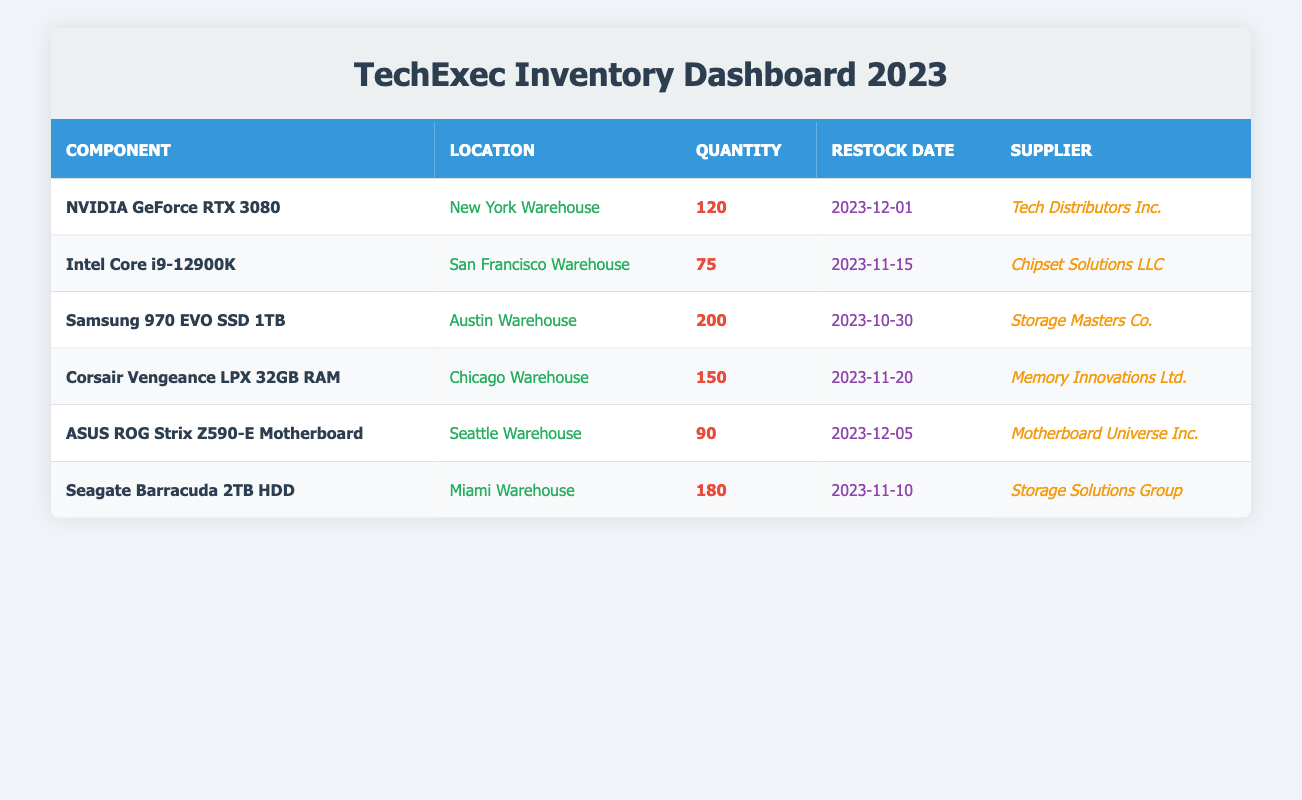What is the total quantity of NVIDIA GeForce RTX 3080 available in the inventory? The table lists the NVIDIA GeForce RTX 3080 with a quantity of 120 in the New York Warehouse, and there are no other entries for this component. Thus, the total quantity is simply 120.
Answer: 120 Which location has the highest stock of hardware components? The table shows various components along with their quantities at different locations. The highest quantity is 200 for the Samsung 970 EVO SSD 1TB at the Austin Warehouse. Therefore, Austin has the highest stock.
Answer: Austin Warehouse Is the Intel Core i9-12900K scheduled for restock before the Seagate Barracuda 2TB HDD? The Intel Core i9-12900K has a restock date of 2023-11-15, while the Seagate Barracuda 2TB HDD has a restock date of 2023-11-10. Since November 10 is before November 15, the statement is true.
Answer: Yes What is the average quantity of the components held in stock across all listed locations? The total stock is calculated by summing the quantities: (120 + 75 + 200 + 150 + 90 + 180) = 915. There are 6 components, so the average is 915 / 6 = 152.5.
Answer: 152.5 How many components have a quantity greater than 100 in stock? Examining the table, the components with quantities above 100 are the NVIDIA GeForce RTX 3080 (120), Samsung 970 EVO SSD 1TB (200), Corsair Vengeance LPX 32GB RAM (150), and Seagate Barracuda 2TB HDD (180). Thus, there are 4 components.
Answer: 4 Is there a supplier for the ASUS ROG Strix Z590-E Motherboard listed in the table? The entry for the ASUS ROG Strix Z590-E Motherboard states its supplier is Motherboard Universe Inc. Therefore, the answer to whether a supplier is listed is affirmative.
Answer: Yes What is the difference in stock quantity between the highest and lowest quantity components? The highest stock is 200 (Samsung 970 EVO SSD 1TB) and the lowest is 75 (Intel Core i9-12900K). The difference is 200 - 75 = 125.
Answer: 125 How many locations feature a restock date in December 2023? The table lists restock dates for two components in December: NVIDIA GeForce RTX 3080 (2023-12-01) and ASUS ROG Strix Z590-E Motherboard (2023-12-05). Therefore, there are 2 locations featuring December restock dates.
Answer: 2 Does the Miami Warehouse have an adequate supply of the Seagate Barracuda 2TB HDD? The Miami Warehouse holds 180 units of the Seagate Barracuda 2TB HDD, which is a significant quantity for a typical hardware stock, indicating adequate supply. Hence, the answer is yes.
Answer: Yes 